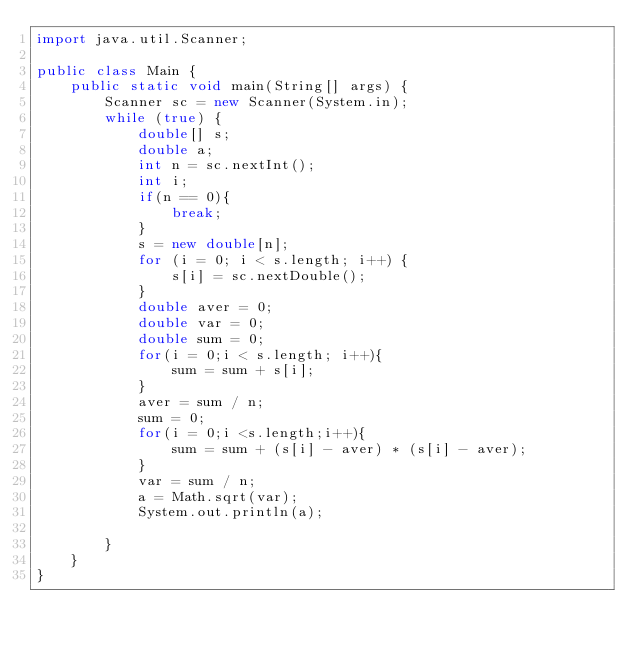Convert code to text. <code><loc_0><loc_0><loc_500><loc_500><_Java_>import java.util.Scanner;

public class Main {
	public static void main(String[] args) {
		Scanner sc = new Scanner(System.in);
		while (true) {
			double[] s;
			double a;
			int n = sc.nextInt();
			int i;
			if(n == 0){
				break;
			}
			s = new double[n];
			for (i = 0; i < s.length; i++) {
				s[i] = sc.nextDouble();
			}
			double aver = 0;
			double var = 0;
			double sum = 0;
			for(i = 0;i < s.length; i++){
				sum = sum + s[i];
			}
			aver = sum / n;
			sum = 0;
			for(i = 0;i <s.length;i++){
				sum = sum + (s[i] - aver) * (s[i] - aver);
			}
			var = sum / n;
			a = Math.sqrt(var);
			System.out.println(a);

		}
	}
}</code> 